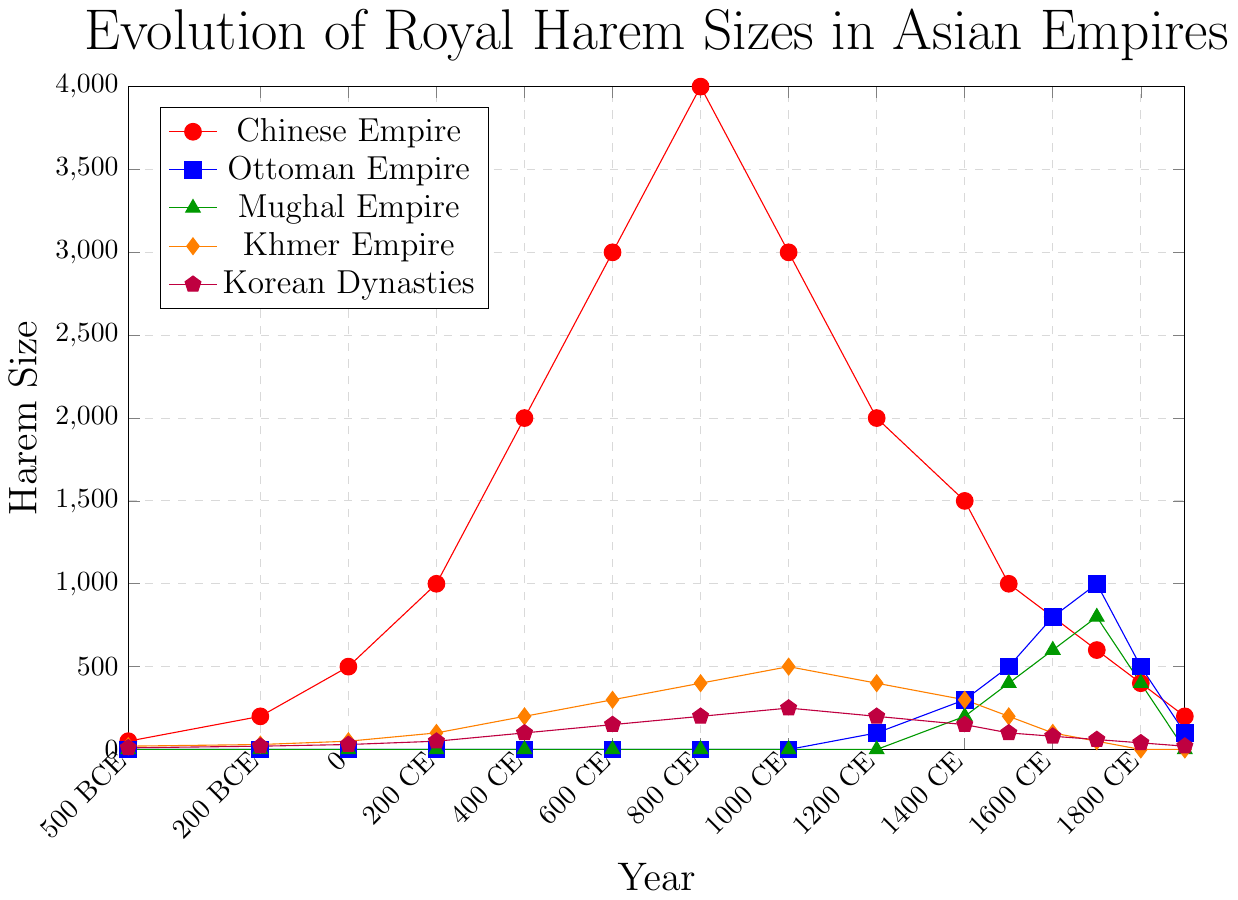Which empire had the largest harem size in 800 CE? To determine this, look for the data points along the 800 CE mark for each empire and compare them. The Chinese Empire (4000) has the largest harem size.
Answer: Chinese Empire What was the general trend of the Chinese Empire's harem size from 500 BCE to 1900 CE? Observing the line representing the Chinese Empire, there is an increase until 800 CE, peaking at 4000, then a decline until 1900 CE, ending at 200.
Answer: Increase until 800 CE, then decrease Compare the harem sizes of the Mughal and Ottoman Empires in 1700 CE. Which was larger? Find and compare the data points for both empires at 1700 CE. The Mughal Empire (800) is equal to the Ottoman Empire (1000).
Answer: Ottoman Empire Identify the period during which the Korean Dynasties had the most notable growth in harem size. Determine the periods with the steepest increase in the Korean Dynasties' line. The steepest growth occurred between 800 CE (200) and 1000 CE (250).
Answer: 800 CE to 1000 CE Calculate the average harem size of the Khmer Empire from 500 BCE to 1900 CE. Sum the data points for the Khmer Empire and divide by the number of points: (20+30+50+100+200+300+400+500+400+300+200+100+50+0+0)/15 = 165.
Answer: 165 At what point did the harem size of the Ottoman Empire peak, and what was that size? Look for the highest value in the Ottoman Empire's data and identify the corresponding year. The peak was 1000 in 1700 CE.
Answer: 1700 CE, 1000 Which two empires saw a decline in their harem sizes starting from 1000 CE? Check the lines from 1000 CE onwards and identify which empires show a decreasing trend. The Chinese Empire and Khmer Empire both declined.
Answer: Chinese Empire and Khmer Empire How did the harem size of the Chinese Empire in 0 CE compare to the Korean Dynasties in 0 CE? Compare the corresponding values at 0 CE, Chinese Empire (500) and Korean Dynasties (30). The Chinese Empire was significantly larger.
Answer: Chinese Empire larger Between 1200 CE and 1400 CE, which empire’s harem size increased the most? Check the values at 1200 CE and 1400 CE and calculate the difference for each empire. The Ottoman Empire increased the most (300 - 100 = 200).
Answer: Ottoman Empire In which centuries did the Khmer Empire and the Korean Dynasties both show a decline in harem size? Identify centuries where both lines show a decrease. From 1400 CE to 1600 CE, both empires show a decline.
Answer: 1400 CE to 1600 CE 